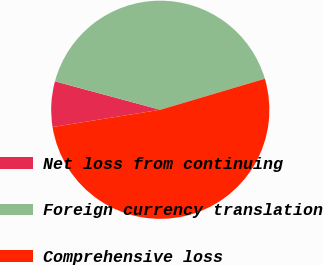Convert chart. <chart><loc_0><loc_0><loc_500><loc_500><pie_chart><fcel>Net loss from continuing<fcel>Foreign currency translation<fcel>Comprehensive loss<nl><fcel>6.73%<fcel>41.21%<fcel>52.06%<nl></chart> 